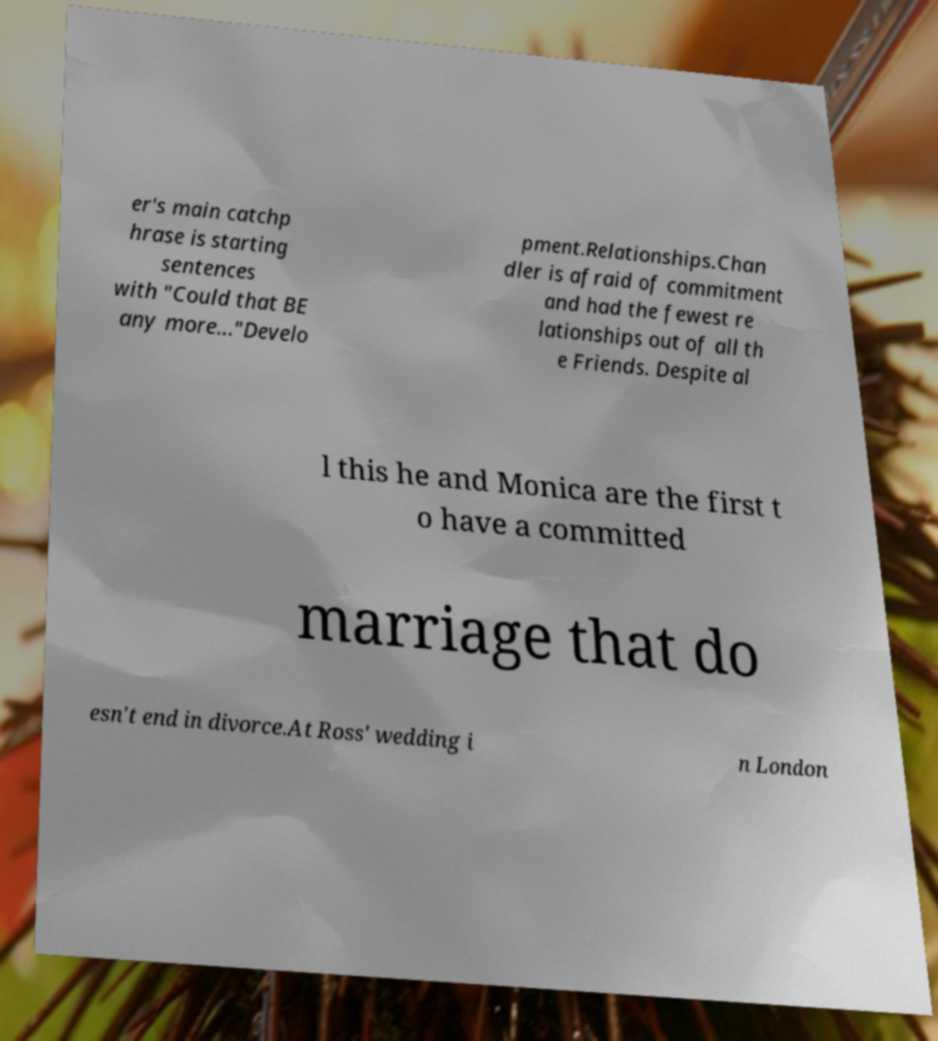Could you assist in decoding the text presented in this image and type it out clearly? er's main catchp hrase is starting sentences with "Could that BE any more..."Develo pment.Relationships.Chan dler is afraid of commitment and had the fewest re lationships out of all th e Friends. Despite al l this he and Monica are the first t o have a committed marriage that do esn't end in divorce.At Ross' wedding i n London 